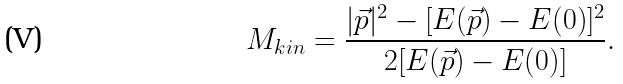<formula> <loc_0><loc_0><loc_500><loc_500>M _ { k i n } = \frac { | \vec { p } | ^ { 2 } - [ E ( \vec { p } ) - E ( 0 ) ] ^ { 2 } } { 2 [ E ( \vec { p } ) - E ( 0 ) ] } .</formula> 